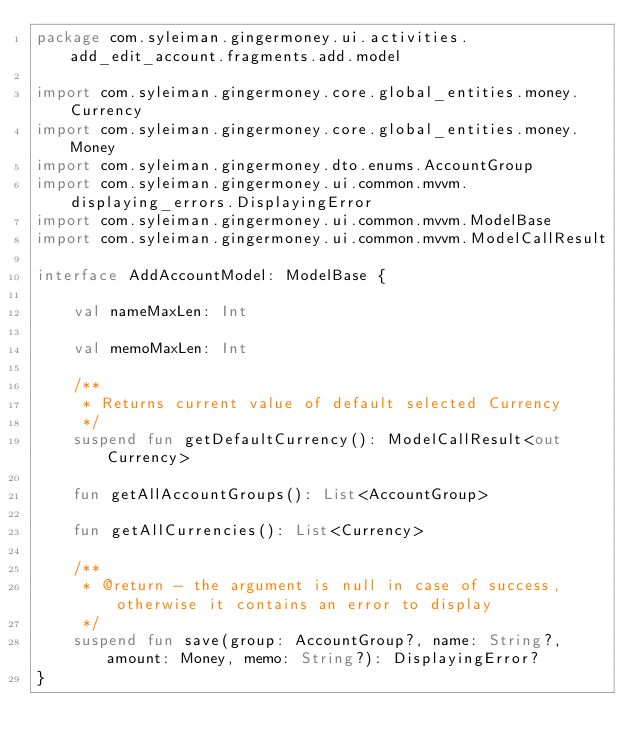<code> <loc_0><loc_0><loc_500><loc_500><_Kotlin_>package com.syleiman.gingermoney.ui.activities.add_edit_account.fragments.add.model

import com.syleiman.gingermoney.core.global_entities.money.Currency
import com.syleiman.gingermoney.core.global_entities.money.Money
import com.syleiman.gingermoney.dto.enums.AccountGroup
import com.syleiman.gingermoney.ui.common.mvvm.displaying_errors.DisplayingError
import com.syleiman.gingermoney.ui.common.mvvm.ModelBase
import com.syleiman.gingermoney.ui.common.mvvm.ModelCallResult

interface AddAccountModel: ModelBase {

    val nameMaxLen: Int

    val memoMaxLen: Int

    /**
     * Returns current value of default selected Currency
     */
    suspend fun getDefaultCurrency(): ModelCallResult<out Currency>

    fun getAllAccountGroups(): List<AccountGroup>

    fun getAllCurrencies(): List<Currency>

    /**
     * @return - the argument is null in case of success, otherwise it contains an error to display
     */
    suspend fun save(group: AccountGroup?, name: String?, amount: Money, memo: String?): DisplayingError?
}</code> 